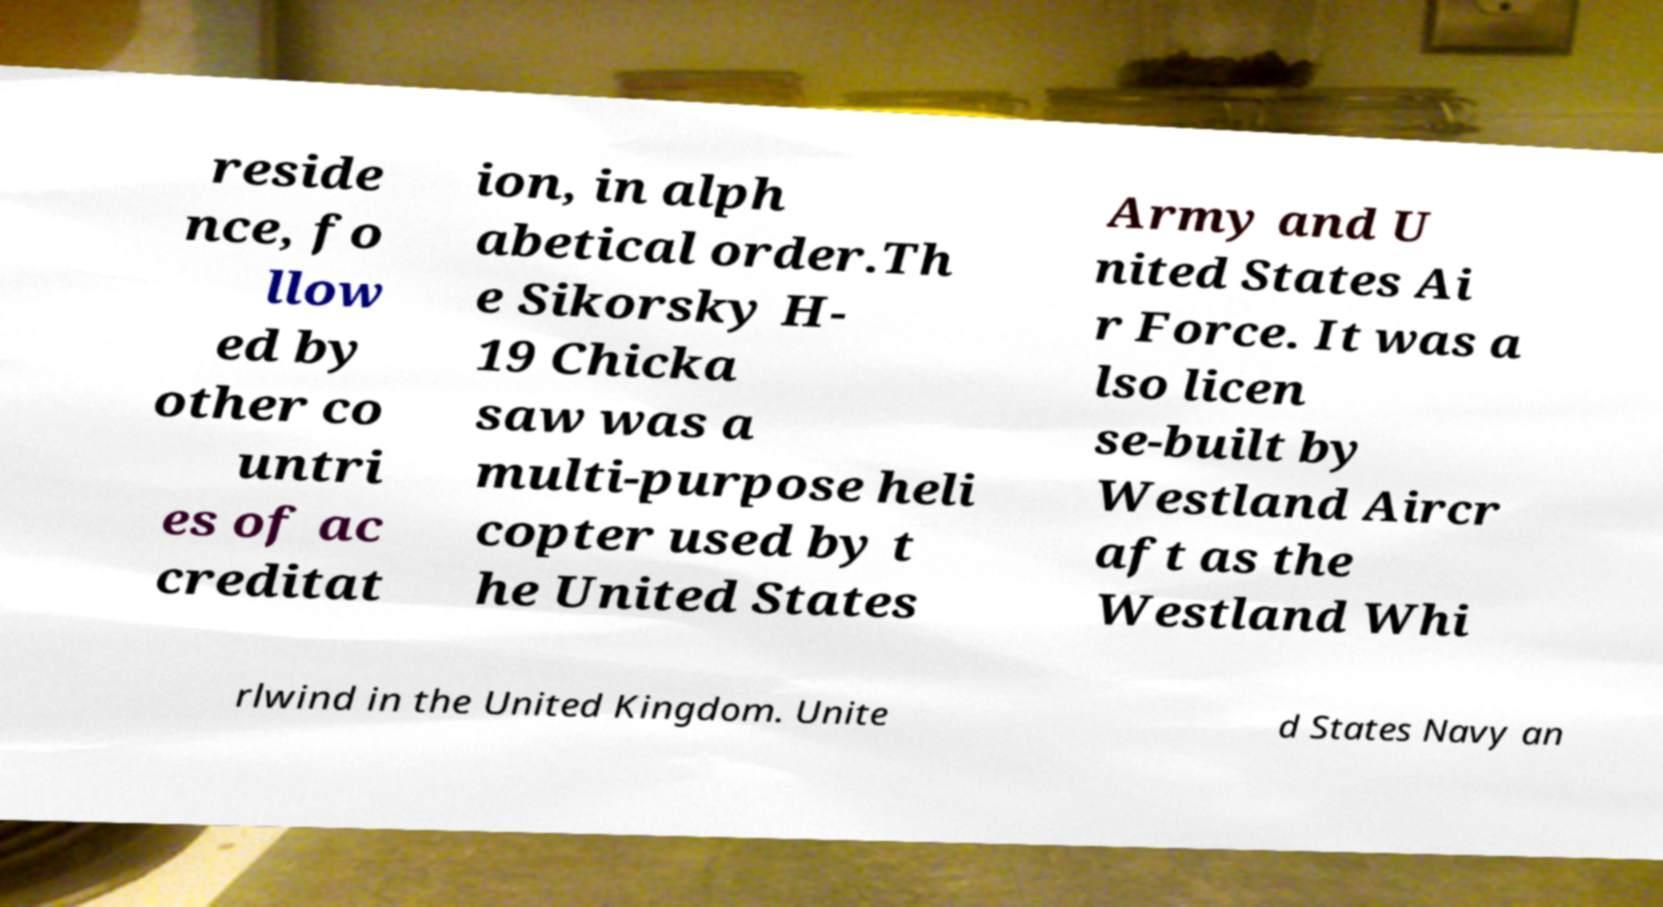There's text embedded in this image that I need extracted. Can you transcribe it verbatim? reside nce, fo llow ed by other co untri es of ac creditat ion, in alph abetical order.Th e Sikorsky H- 19 Chicka saw was a multi-purpose heli copter used by t he United States Army and U nited States Ai r Force. It was a lso licen se-built by Westland Aircr aft as the Westland Whi rlwind in the United Kingdom. Unite d States Navy an 